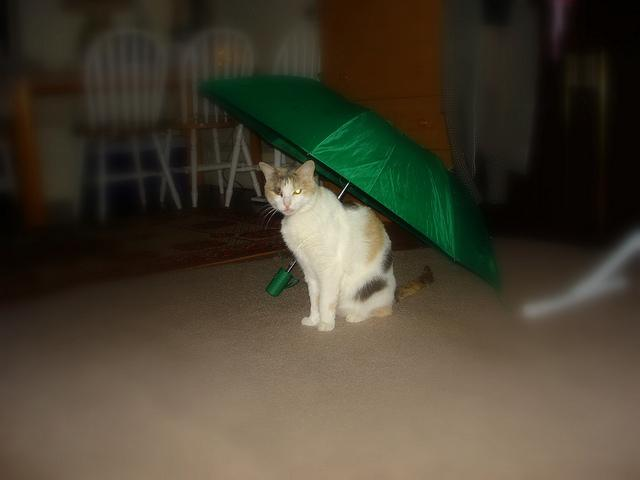What object used to prevent getting wet is nearby the cat in this image? Please explain your reasoning. umbrella. The umbrella protects you from the rain. 